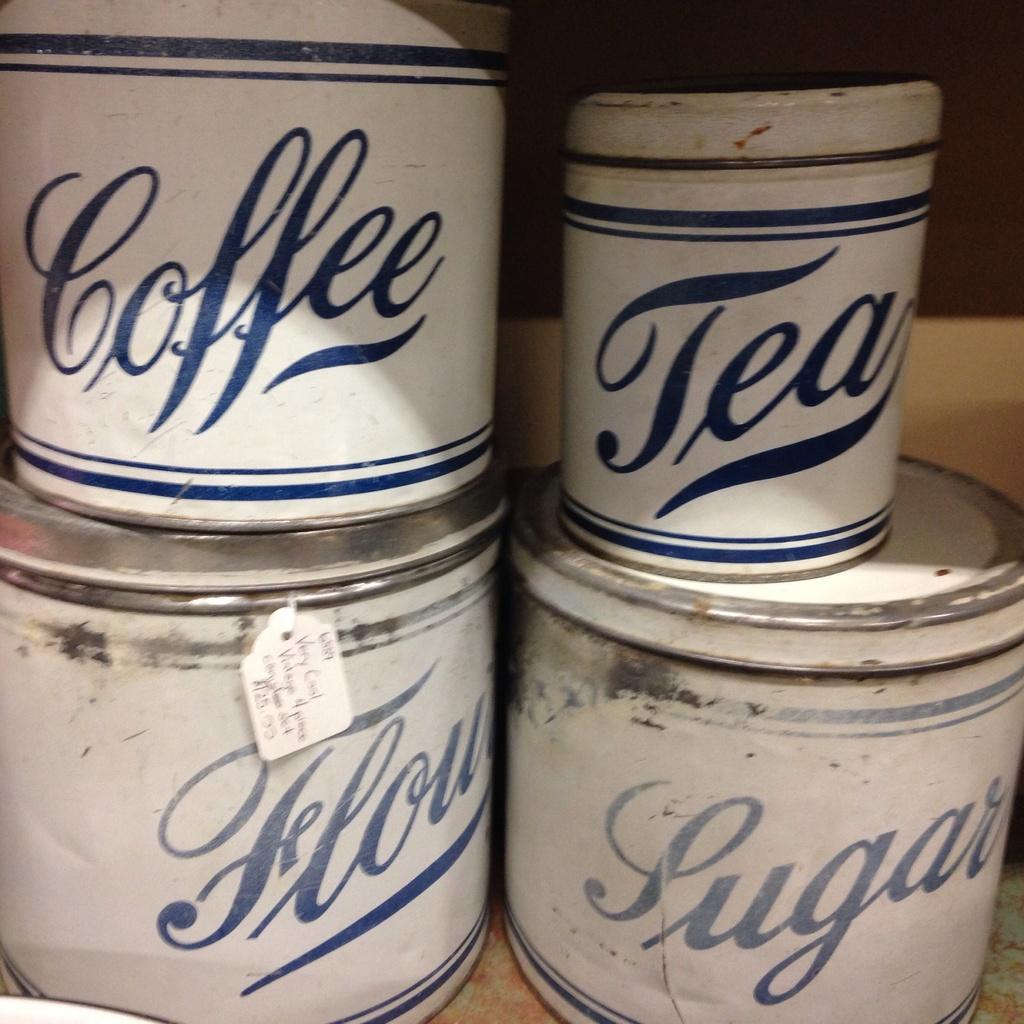<image>
Create a compact narrative representing the image presented. coffee and tea items that are stacked with each other 